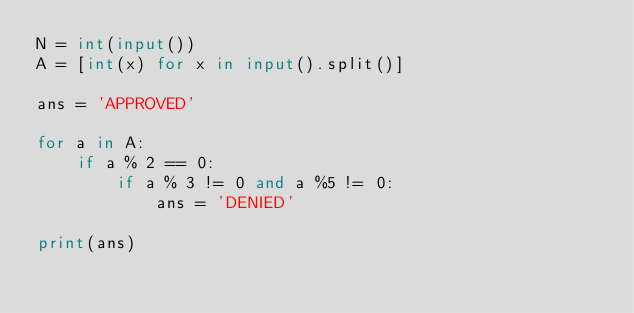<code> <loc_0><loc_0><loc_500><loc_500><_Python_>N = int(input())
A = [int(x) for x in input().split()]

ans = 'APPROVED'

for a in A:
    if a % 2 == 0:
        if a % 3 != 0 and a %5 != 0:
            ans = 'DENIED'

print(ans)
</code> 